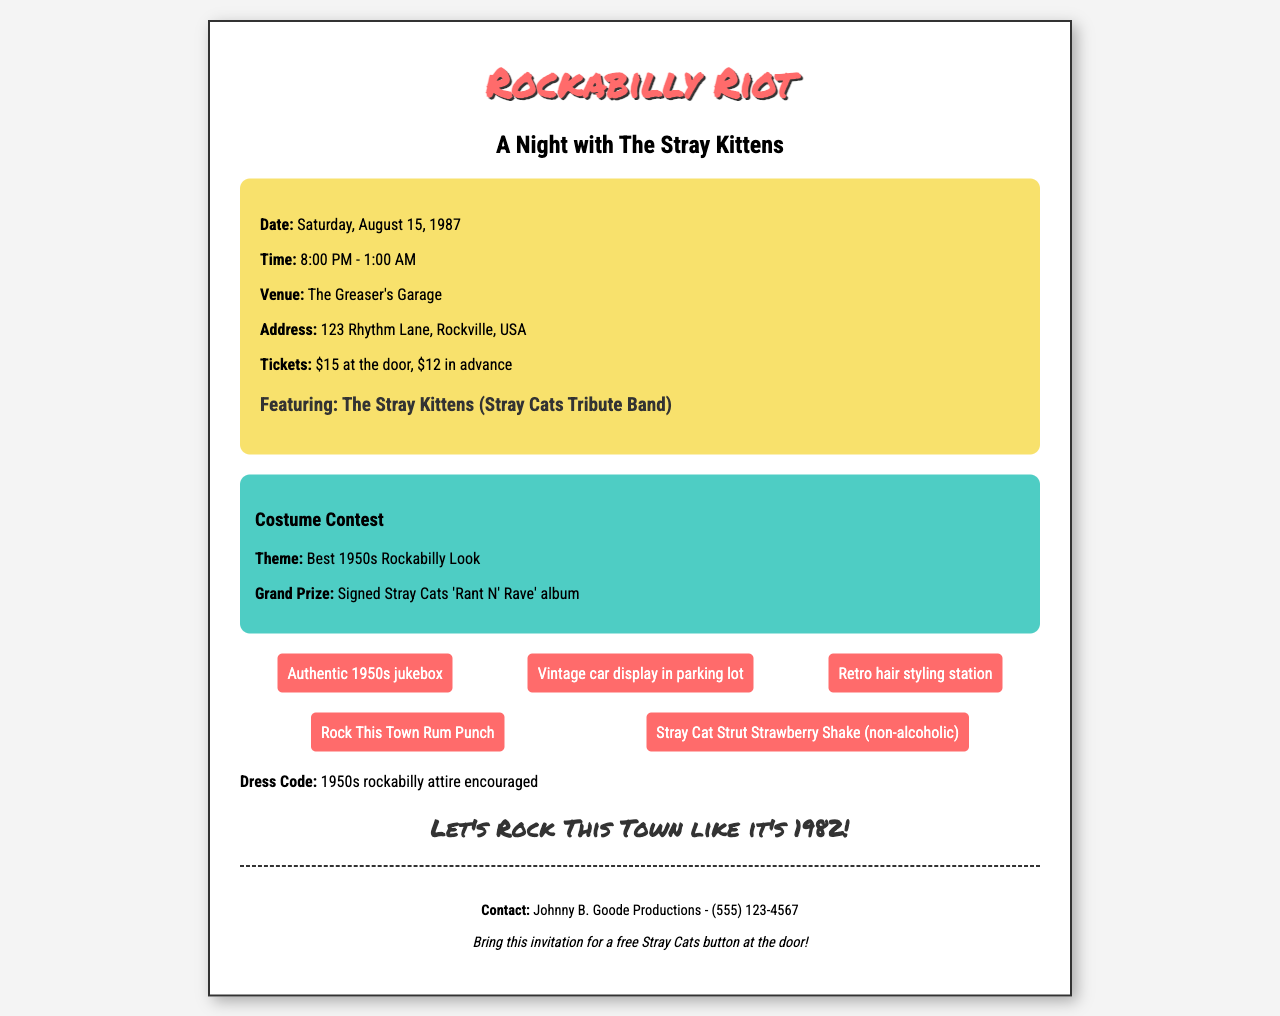what is the date of the event? The date is specified clearly in the document as Saturday, August 15, 1987.
Answer: Saturday, August 15, 1987 what time does the event start? The starting time is mentioned in the event details as 8:00 PM.
Answer: 8:00 PM where is the event being held? The venue is provided in the document, which is The Greaser's Garage.
Answer: The Greaser's Garage what is the grand prize for the costume contest? The document states that the grand prize is a signed Stray Cats 'Rant N' Rave' album.
Answer: Signed Stray Cats 'Rant N' Rave' album what is the price for tickets at the door? The ticket price is listed in the document, which states that tickets are $15 at the door.
Answer: $15 how long will the event last? The duration is provided in the document, from 8:00 PM to 1:00 AM, which is a total of 5 hours.
Answer: 5 hours what should attendees bring for a special offer? The document states to bring the invitation for a free Stray Cats button at the door.
Answer: Free Stray Cats button what theme is set for the costume contest? The theme for the costume contest is mentioned as 'Best 1950s Rockabilly Look'.
Answer: Best 1950s Rockabilly Look what type of music will be featured during the event? The document mentions that the featured band is The Stray Kittens, a tribute band to the Stray Cats.
Answer: The Stray Kittens (Stray Cats Tribute Band) 